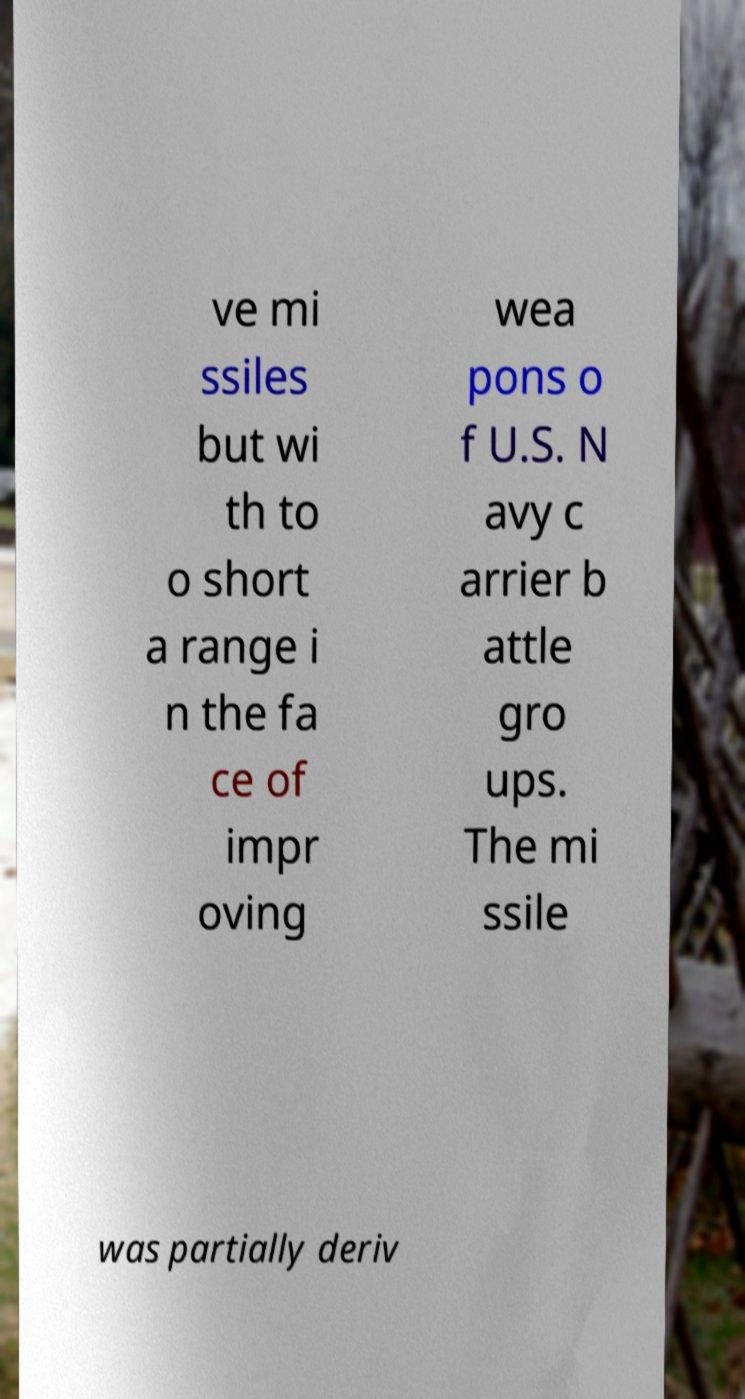Could you assist in decoding the text presented in this image and type it out clearly? ve mi ssiles but wi th to o short a range i n the fa ce of impr oving wea pons o f U.S. N avy c arrier b attle gro ups. The mi ssile was partially deriv 